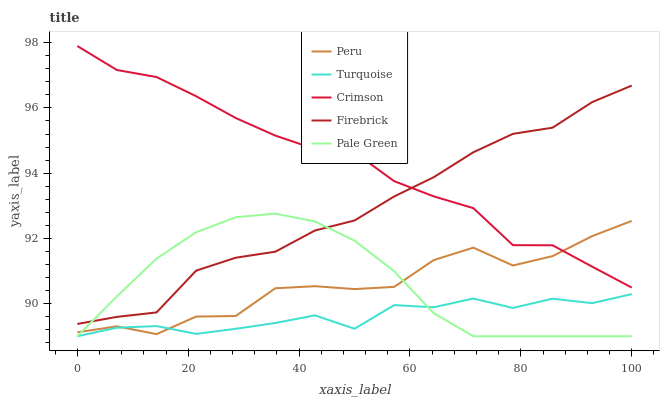Does Pale Green have the minimum area under the curve?
Answer yes or no. No. Does Pale Green have the maximum area under the curve?
Answer yes or no. No. Is Turquoise the smoothest?
Answer yes or no. No. Is Turquoise the roughest?
Answer yes or no. No. Does Firebrick have the lowest value?
Answer yes or no. No. Does Pale Green have the highest value?
Answer yes or no. No. Is Pale Green less than Crimson?
Answer yes or no. Yes. Is Firebrick greater than Peru?
Answer yes or no. Yes. Does Pale Green intersect Crimson?
Answer yes or no. No. 